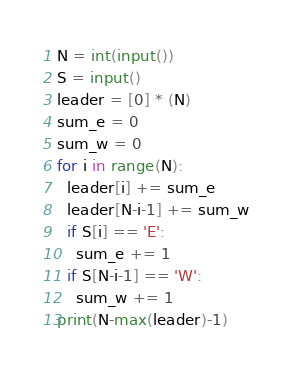Convert code to text. <code><loc_0><loc_0><loc_500><loc_500><_Python_>N = int(input())
S = input()
leader = [0] * (N)
sum_e = 0
sum_w = 0
for i in range(N):
  leader[i] += sum_e
  leader[N-i-1] += sum_w
  if S[i] == 'E':
    sum_e += 1
  if S[N-i-1] == 'W':
    sum_w += 1
print(N-max(leader)-1)</code> 